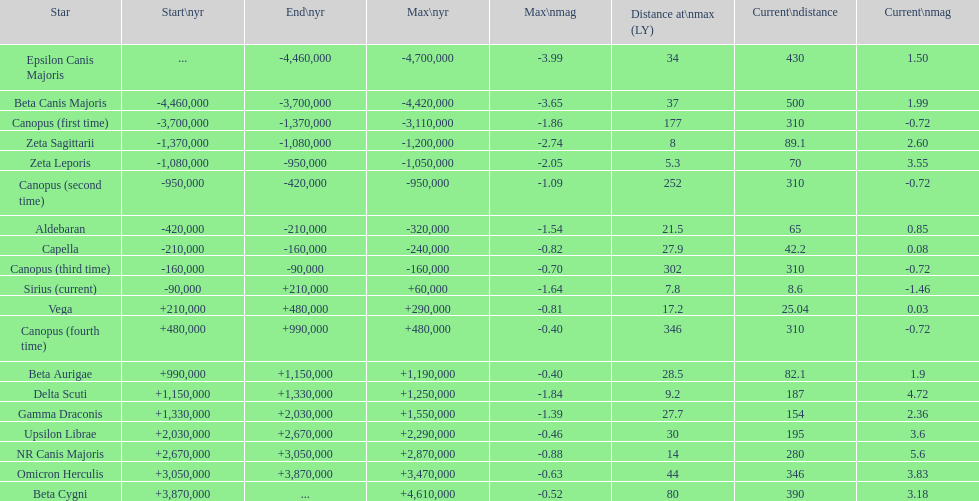What is the number of stars that have a maximum magnitude less than zero? 5. 